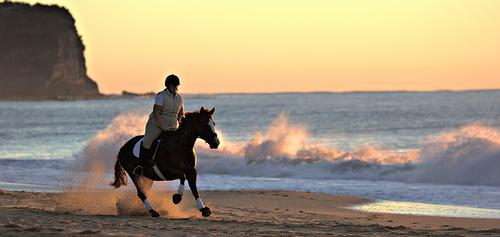Question: where is the image taken?
Choices:
A. At the park.
B. Near to beach.
C. In the backyard.
D. At the playground.
Answer with the letter. Answer: B Question: how the image looks like?
Choices:
A. Dull.
B. Dark.
C. Fun.
D. Exciting.
Answer with the letter. Answer: D Question: when is the image taken?
Choices:
A. Riding.
B. Shopping.
C. Catering.
D. In bed.
Answer with the letter. Answer: A Question: what is the color of horse?
Choices:
A. Black.
B. Brown.
C. Gray.
D. Teal.
Answer with the letter. Answer: A Question: what is the color of water?
Choices:
A. Aqua.
B. Hazel.
C. Green.
D. Blue.
Answer with the letter. Answer: D Question: who is in the image?
Choices:
A. A guy.
B. Horse and lady.
C. The trainer.
D. A steward.
Answer with the letter. Answer: B 